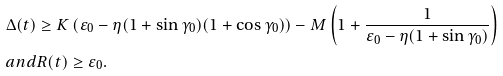Convert formula to latex. <formula><loc_0><loc_0><loc_500><loc_500>& \Delta ( t ) \geq K \left ( \varepsilon _ { 0 } - \eta ( 1 + \sin \gamma _ { 0 } ) ( 1 + \cos \gamma _ { 0 } ) \right ) - M \left ( 1 + \frac { 1 } { \varepsilon _ { 0 } - \eta ( 1 + \sin \gamma _ { 0 } ) } \right ) \\ & a n d R ( t ) \geq \varepsilon _ { 0 } .</formula> 